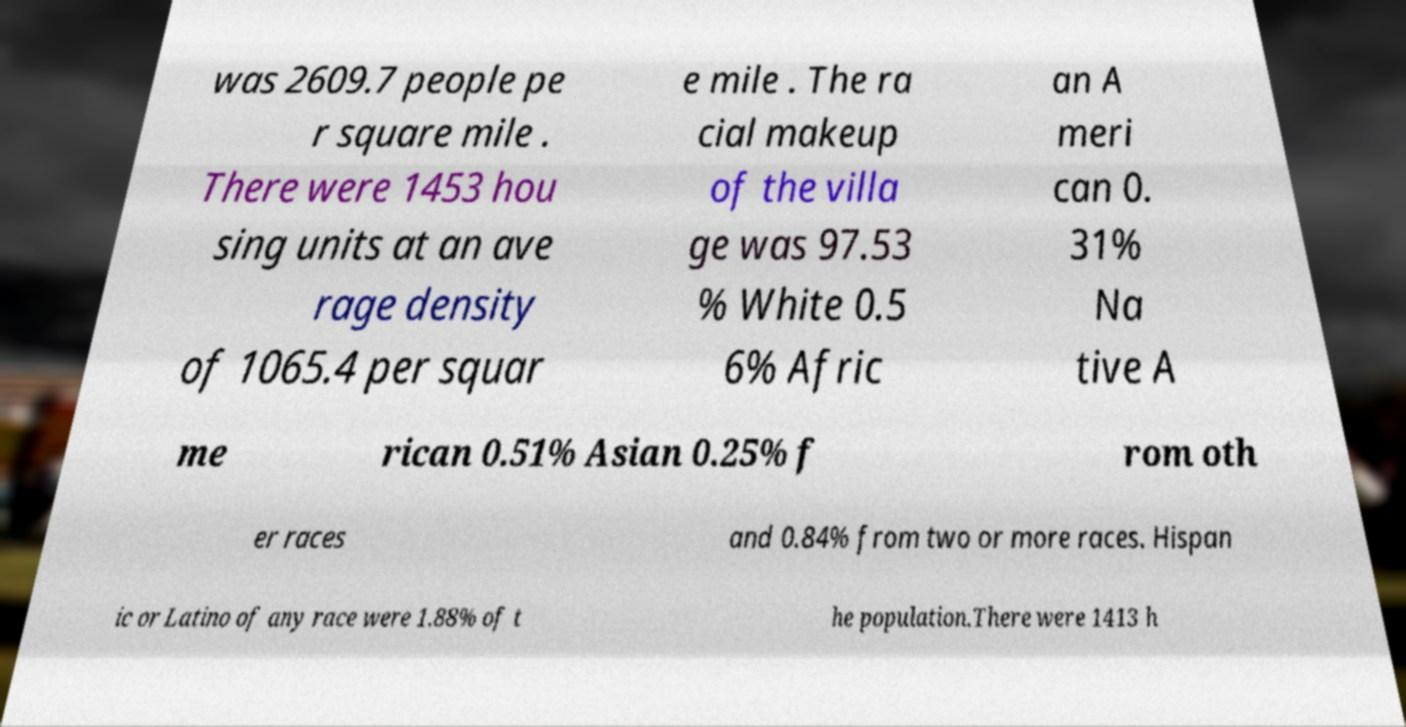There's text embedded in this image that I need extracted. Can you transcribe it verbatim? was 2609.7 people pe r square mile . There were 1453 hou sing units at an ave rage density of 1065.4 per squar e mile . The ra cial makeup of the villa ge was 97.53 % White 0.5 6% Afric an A meri can 0. 31% Na tive A me rican 0.51% Asian 0.25% f rom oth er races and 0.84% from two or more races. Hispan ic or Latino of any race were 1.88% of t he population.There were 1413 h 